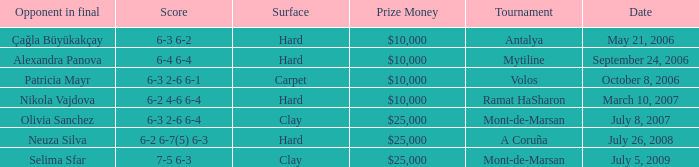What is the surface for the Volos tournament? Carpet. Could you parse the entire table as a dict? {'header': ['Opponent in final', 'Score', 'Surface', 'Prize Money', 'Tournament', 'Date'], 'rows': [['Çağla Büyükakçay', '6-3 6-2', 'Hard', '$10,000', 'Antalya', 'May 21, 2006'], ['Alexandra Panova', '6-4 6-4', 'Hard', '$10,000', 'Mytiline', 'September 24, 2006'], ['Patricia Mayr', '6-3 2-6 6-1', 'Carpet', '$10,000', 'Volos', 'October 8, 2006'], ['Nikola Vajdova', '6-2 4-6 6-4', 'Hard', '$10,000', 'Ramat HaSharon', 'March 10, 2007'], ['Olivia Sanchez', '6-3 2-6 6-4', 'Clay', '$25,000', 'Mont-de-Marsan', 'July 8, 2007'], ['Neuza Silva', '6-2 6-7(5) 6-3', 'Hard', '$25,000', 'A Coruña', 'July 26, 2008'], ['Selima Sfar', '7-5 6-3', 'Clay', '$25,000', 'Mont-de-Marsan', 'July 5, 2009']]} 